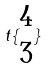Convert formula to latex. <formula><loc_0><loc_0><loc_500><loc_500>t \{ \begin{matrix} 4 \\ 3 \end{matrix} \}</formula> 